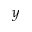<formula> <loc_0><loc_0><loc_500><loc_500>y</formula> 